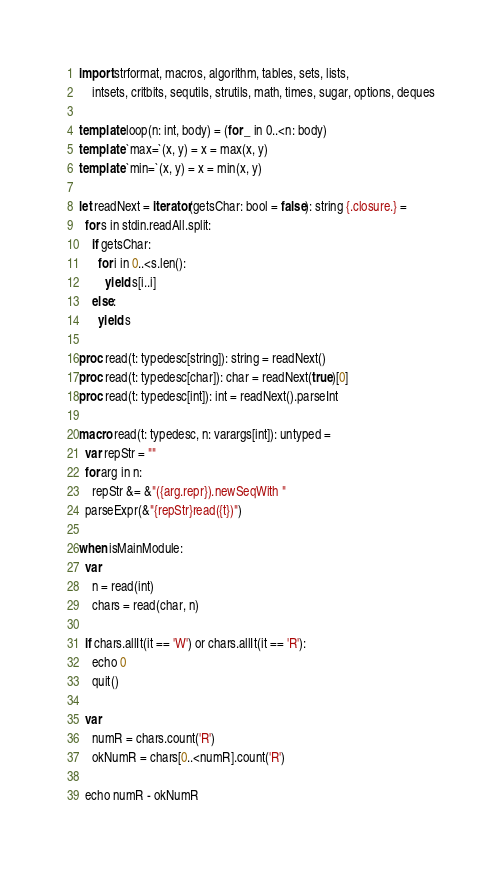<code> <loc_0><loc_0><loc_500><loc_500><_Nim_>import strformat, macros, algorithm, tables, sets, lists,
    intsets, critbits, sequtils, strutils, math, times, sugar, options, deques

template loop(n: int, body) = (for _ in 0..<n: body)
template `max=`(x, y) = x = max(x, y)
template `min=`(x, y) = x = min(x, y)

let readNext = iterator(getsChar: bool = false): string {.closure.} =
  for s in stdin.readAll.split:
    if getsChar:
      for i in 0..<s.len():
        yield s[i..i]
    else:
      yield s

proc read(t: typedesc[string]): string = readNext()
proc read(t: typedesc[char]): char = readNext(true)[0]
proc read(t: typedesc[int]): int = readNext().parseInt

macro read(t: typedesc, n: varargs[int]): untyped =
  var repStr = ""
  for arg in n:
    repStr &= &"({arg.repr}).newSeqWith "
  parseExpr(&"{repStr}read({t})")

when isMainModule:
  var
    n = read(int)
    chars = read(char, n)

  if chars.allIt(it == 'W') or chars.allIt(it == 'R'):
    echo 0
    quit()

  var
    numR = chars.count('R')
    okNumR = chars[0..<numR].count('R')

  echo numR - okNumR
</code> 